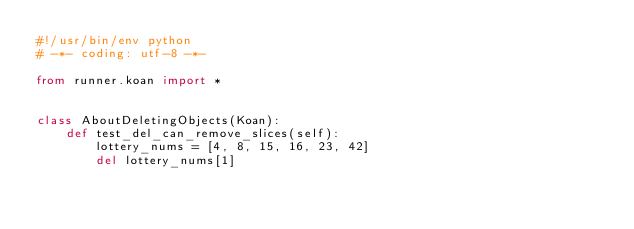<code> <loc_0><loc_0><loc_500><loc_500><_Python_>#!/usr/bin/env python
# -*- coding: utf-8 -*-

from runner.koan import *


class AboutDeletingObjects(Koan):
    def test_del_can_remove_slices(self):
        lottery_nums = [4, 8, 15, 16, 23, 42]
        del lottery_nums[1]</code> 